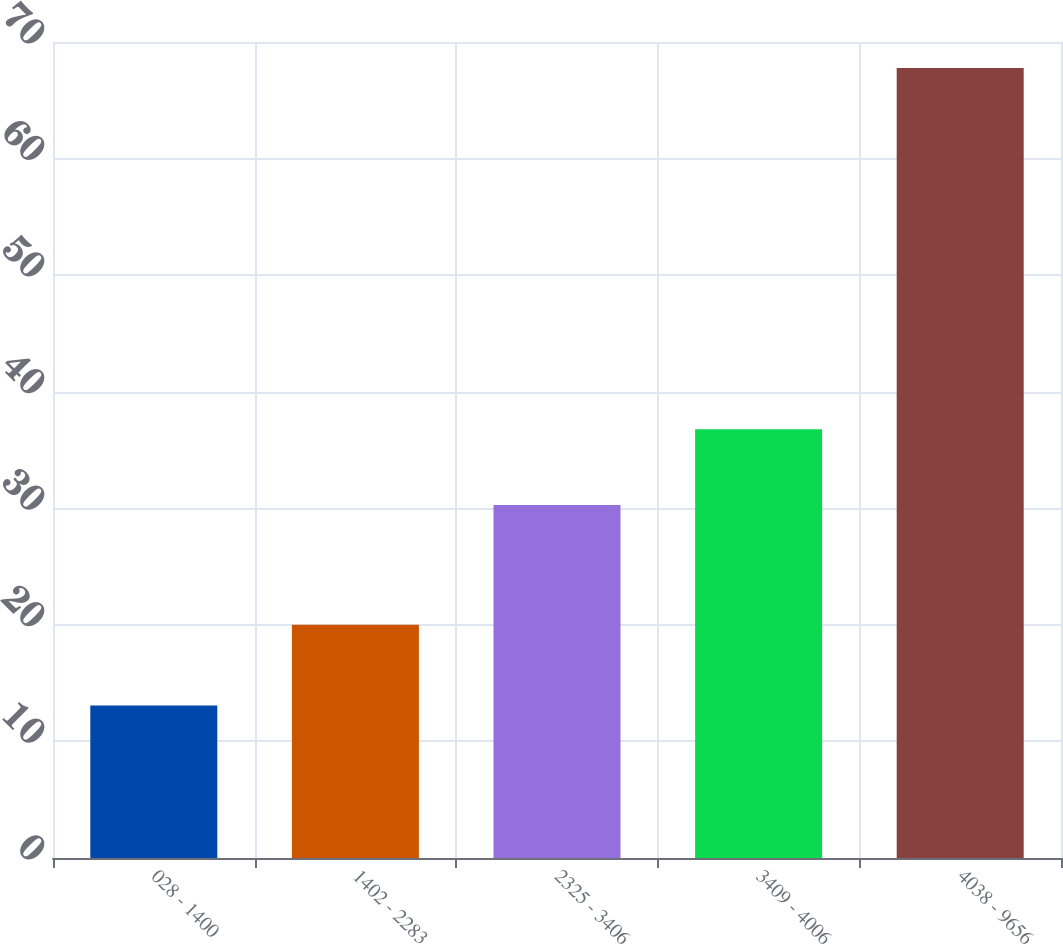<chart> <loc_0><loc_0><loc_500><loc_500><bar_chart><fcel>028 - 1400<fcel>1402 - 2283<fcel>2325 - 3406<fcel>3409 - 4006<fcel>4038 - 9656<nl><fcel>13.09<fcel>20<fcel>30.28<fcel>36.78<fcel>67.78<nl></chart> 